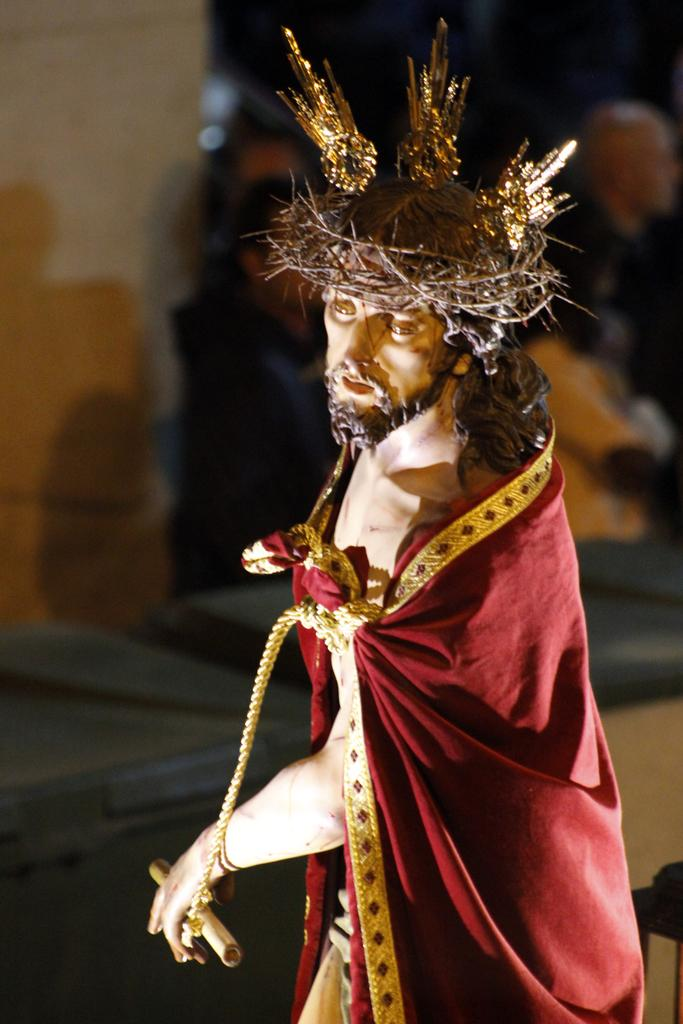What is the main subject of the image? The main subject of the image is a statue of a person. What is on the statue's head? The statue has a crown on its head. What is covering the statue's body? The statue has a cloth covering its body. Are there any other people visible in the image? Yes, there appear to be a few people standing behind the statue. How many sisters are standing next to the statue in the image? There is no mention of sisters in the image, and no sisters are visible. 